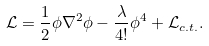<formula> <loc_0><loc_0><loc_500><loc_500>\mathcal { L } = \frac { 1 } { 2 } \phi \nabla ^ { 2 } \phi - \frac { \lambda } { 4 ! } \phi ^ { 4 } + \mathcal { L } _ { c . t . } .</formula> 